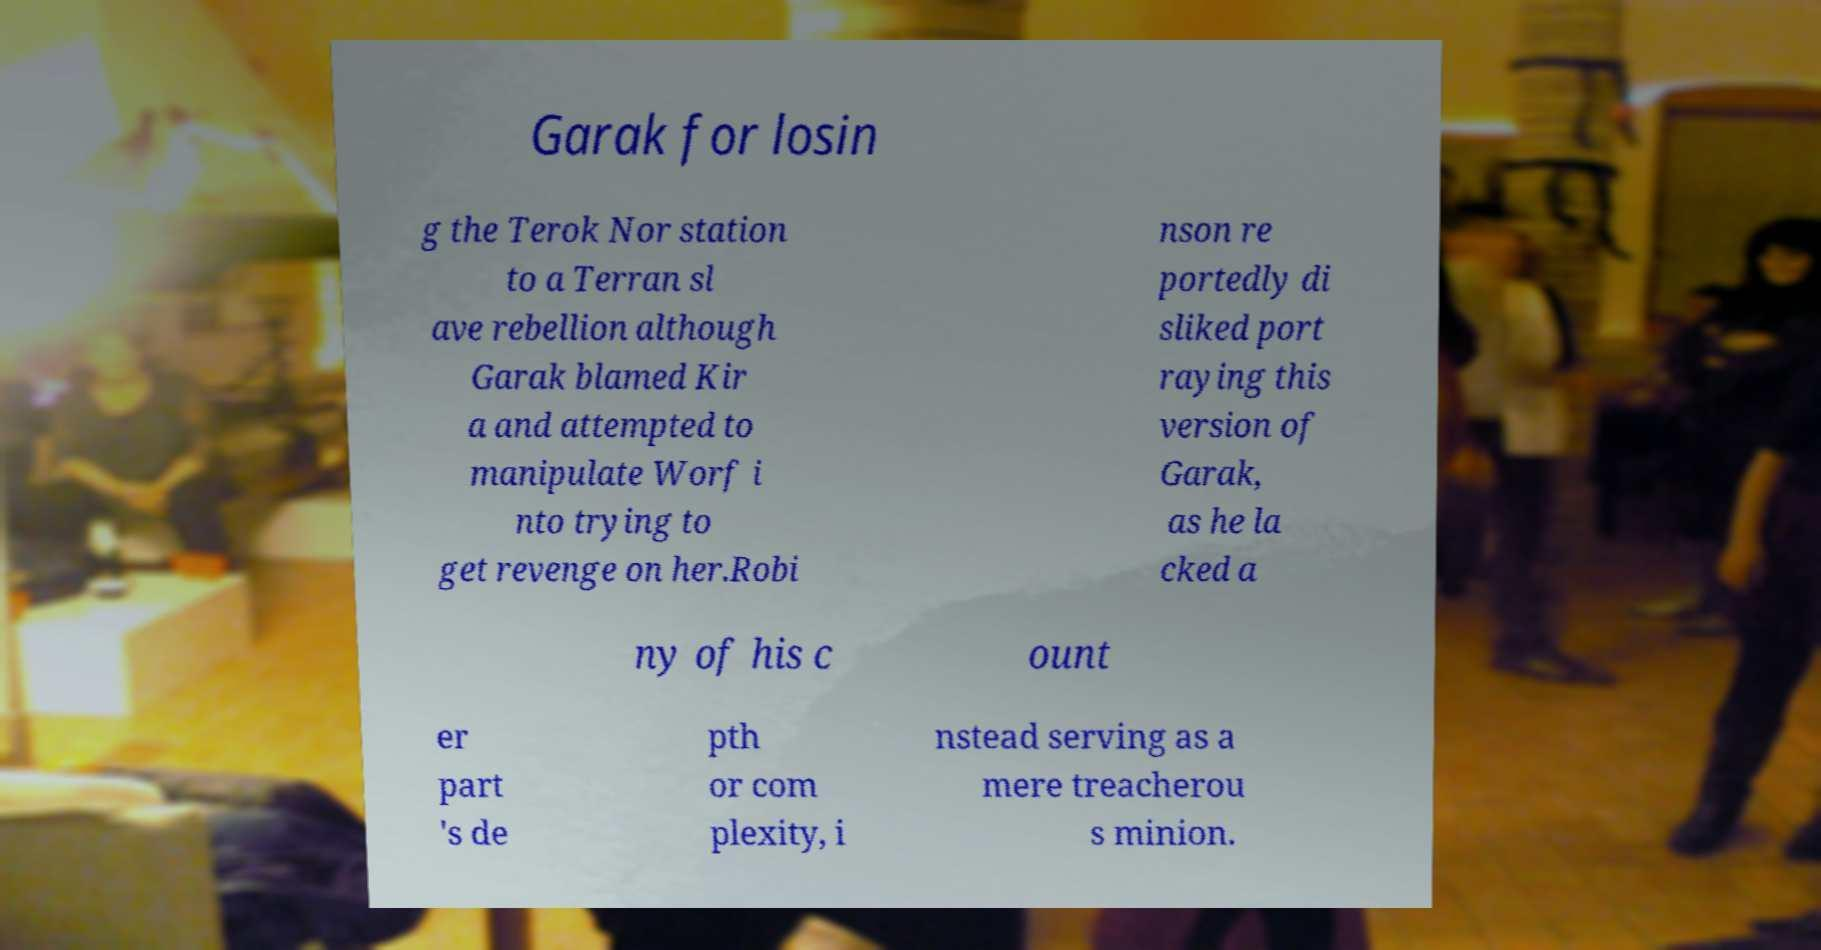For documentation purposes, I need the text within this image transcribed. Could you provide that? Garak for losin g the Terok Nor station to a Terran sl ave rebellion although Garak blamed Kir a and attempted to manipulate Worf i nto trying to get revenge on her.Robi nson re portedly di sliked port raying this version of Garak, as he la cked a ny of his c ount er part 's de pth or com plexity, i nstead serving as a mere treacherou s minion. 